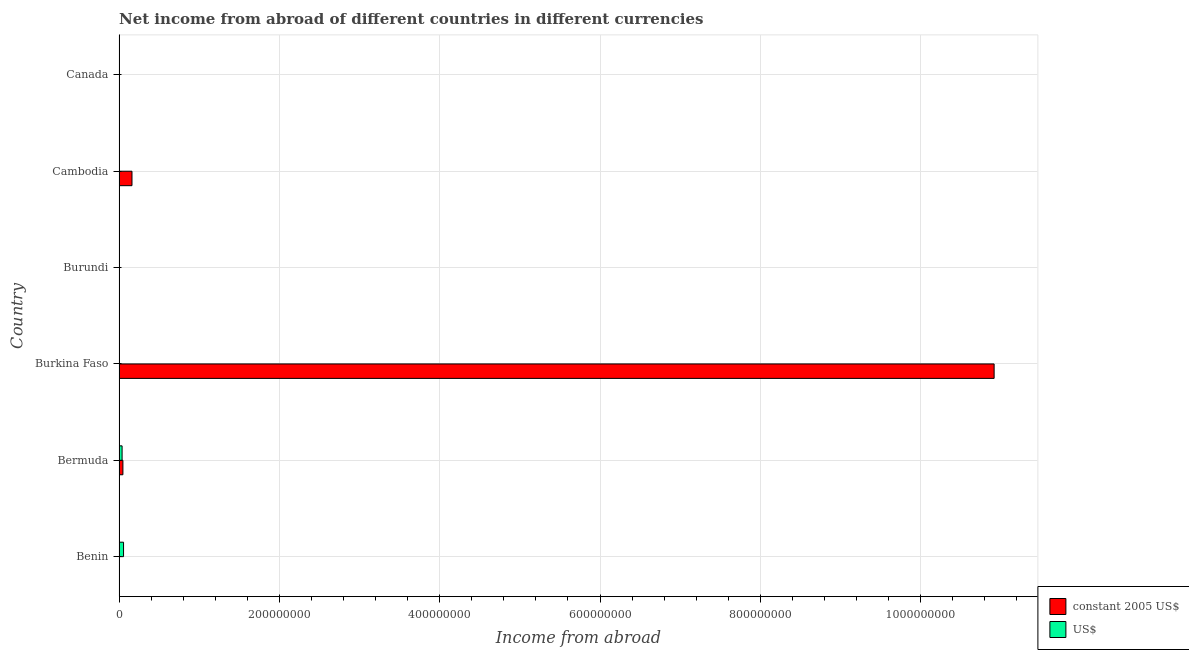Are the number of bars on each tick of the Y-axis equal?
Make the answer very short. No. How many bars are there on the 4th tick from the bottom?
Provide a succinct answer. 1. What is the income from abroad in us$ in Burundi?
Provide a succinct answer. 4.61e+05. Across all countries, what is the maximum income from abroad in constant 2005 us$?
Your response must be concise. 1.09e+09. In which country was the income from abroad in us$ maximum?
Give a very brief answer. Benin. What is the total income from abroad in constant 2005 us$ in the graph?
Provide a short and direct response. 1.11e+09. What is the difference between the income from abroad in constant 2005 us$ in Burkina Faso and that in Cambodia?
Make the answer very short. 1.08e+09. What is the difference between the income from abroad in us$ in Canada and the income from abroad in constant 2005 us$ in Burkina Faso?
Provide a short and direct response. -1.09e+09. What is the average income from abroad in constant 2005 us$ per country?
Provide a succinct answer. 1.85e+08. What is the difference between the income from abroad in us$ and income from abroad in constant 2005 us$ in Bermuda?
Offer a terse response. -1.01e+06. In how many countries, is the income from abroad in constant 2005 us$ greater than 880000000 units?
Keep it short and to the point. 1. What is the ratio of the income from abroad in constant 2005 us$ in Burkina Faso to that in Cambodia?
Your answer should be very brief. 67.64. What is the difference between the highest and the second highest income from abroad in constant 2005 us$?
Offer a terse response. 1.08e+09. What is the difference between the highest and the lowest income from abroad in us$?
Provide a succinct answer. 5.60e+06. Is the sum of the income from abroad in us$ in Benin and Burundi greater than the maximum income from abroad in constant 2005 us$ across all countries?
Provide a short and direct response. No. How many bars are there?
Keep it short and to the point. 6. Does the graph contain grids?
Provide a short and direct response. Yes. Where does the legend appear in the graph?
Offer a very short reply. Bottom right. How are the legend labels stacked?
Provide a succinct answer. Vertical. What is the title of the graph?
Keep it short and to the point. Net income from abroad of different countries in different currencies. What is the label or title of the X-axis?
Your answer should be compact. Income from abroad. What is the Income from abroad of US$ in Benin?
Offer a very short reply. 5.60e+06. What is the Income from abroad in constant 2005 US$ in Bermuda?
Your answer should be very brief. 4.80e+06. What is the Income from abroad of US$ in Bermuda?
Offer a very short reply. 3.79e+06. What is the Income from abroad in constant 2005 US$ in Burkina Faso?
Offer a very short reply. 1.09e+09. What is the Income from abroad in US$ in Burkina Faso?
Give a very brief answer. 0. What is the Income from abroad in constant 2005 US$ in Burundi?
Your answer should be compact. 0. What is the Income from abroad in US$ in Burundi?
Offer a terse response. 4.61e+05. What is the Income from abroad of constant 2005 US$ in Cambodia?
Offer a terse response. 1.61e+07. Across all countries, what is the maximum Income from abroad in constant 2005 US$?
Offer a terse response. 1.09e+09. Across all countries, what is the maximum Income from abroad of US$?
Your response must be concise. 5.60e+06. Across all countries, what is the minimum Income from abroad of US$?
Your response must be concise. 0. What is the total Income from abroad of constant 2005 US$ in the graph?
Offer a very short reply. 1.11e+09. What is the total Income from abroad of US$ in the graph?
Your answer should be compact. 9.85e+06. What is the difference between the Income from abroad in US$ in Benin and that in Bermuda?
Your answer should be compact. 1.81e+06. What is the difference between the Income from abroad of US$ in Benin and that in Burundi?
Your response must be concise. 5.14e+06. What is the difference between the Income from abroad in constant 2005 US$ in Bermuda and that in Burkina Faso?
Your answer should be very brief. -1.09e+09. What is the difference between the Income from abroad of US$ in Bermuda and that in Burundi?
Your answer should be compact. 3.33e+06. What is the difference between the Income from abroad of constant 2005 US$ in Bermuda and that in Cambodia?
Make the answer very short. -1.13e+07. What is the difference between the Income from abroad in constant 2005 US$ in Burkina Faso and that in Cambodia?
Keep it short and to the point. 1.08e+09. What is the difference between the Income from abroad of constant 2005 US$ in Bermuda and the Income from abroad of US$ in Burundi?
Your answer should be very brief. 4.34e+06. What is the difference between the Income from abroad of constant 2005 US$ in Burkina Faso and the Income from abroad of US$ in Burundi?
Your answer should be compact. 1.09e+09. What is the average Income from abroad of constant 2005 US$ per country?
Keep it short and to the point. 1.85e+08. What is the average Income from abroad in US$ per country?
Give a very brief answer. 1.64e+06. What is the difference between the Income from abroad of constant 2005 US$ and Income from abroad of US$ in Bermuda?
Ensure brevity in your answer.  1.01e+06. What is the ratio of the Income from abroad of US$ in Benin to that in Bermuda?
Your answer should be compact. 1.48. What is the ratio of the Income from abroad in US$ in Benin to that in Burundi?
Provide a short and direct response. 12.15. What is the ratio of the Income from abroad in constant 2005 US$ in Bermuda to that in Burkina Faso?
Make the answer very short. 0. What is the ratio of the Income from abroad in US$ in Bermuda to that in Burundi?
Give a very brief answer. 8.23. What is the ratio of the Income from abroad in constant 2005 US$ in Bermuda to that in Cambodia?
Provide a succinct answer. 0.3. What is the ratio of the Income from abroad of constant 2005 US$ in Burkina Faso to that in Cambodia?
Keep it short and to the point. 67.64. What is the difference between the highest and the second highest Income from abroad of constant 2005 US$?
Provide a short and direct response. 1.08e+09. What is the difference between the highest and the second highest Income from abroad of US$?
Offer a very short reply. 1.81e+06. What is the difference between the highest and the lowest Income from abroad of constant 2005 US$?
Your answer should be compact. 1.09e+09. What is the difference between the highest and the lowest Income from abroad in US$?
Your answer should be very brief. 5.60e+06. 